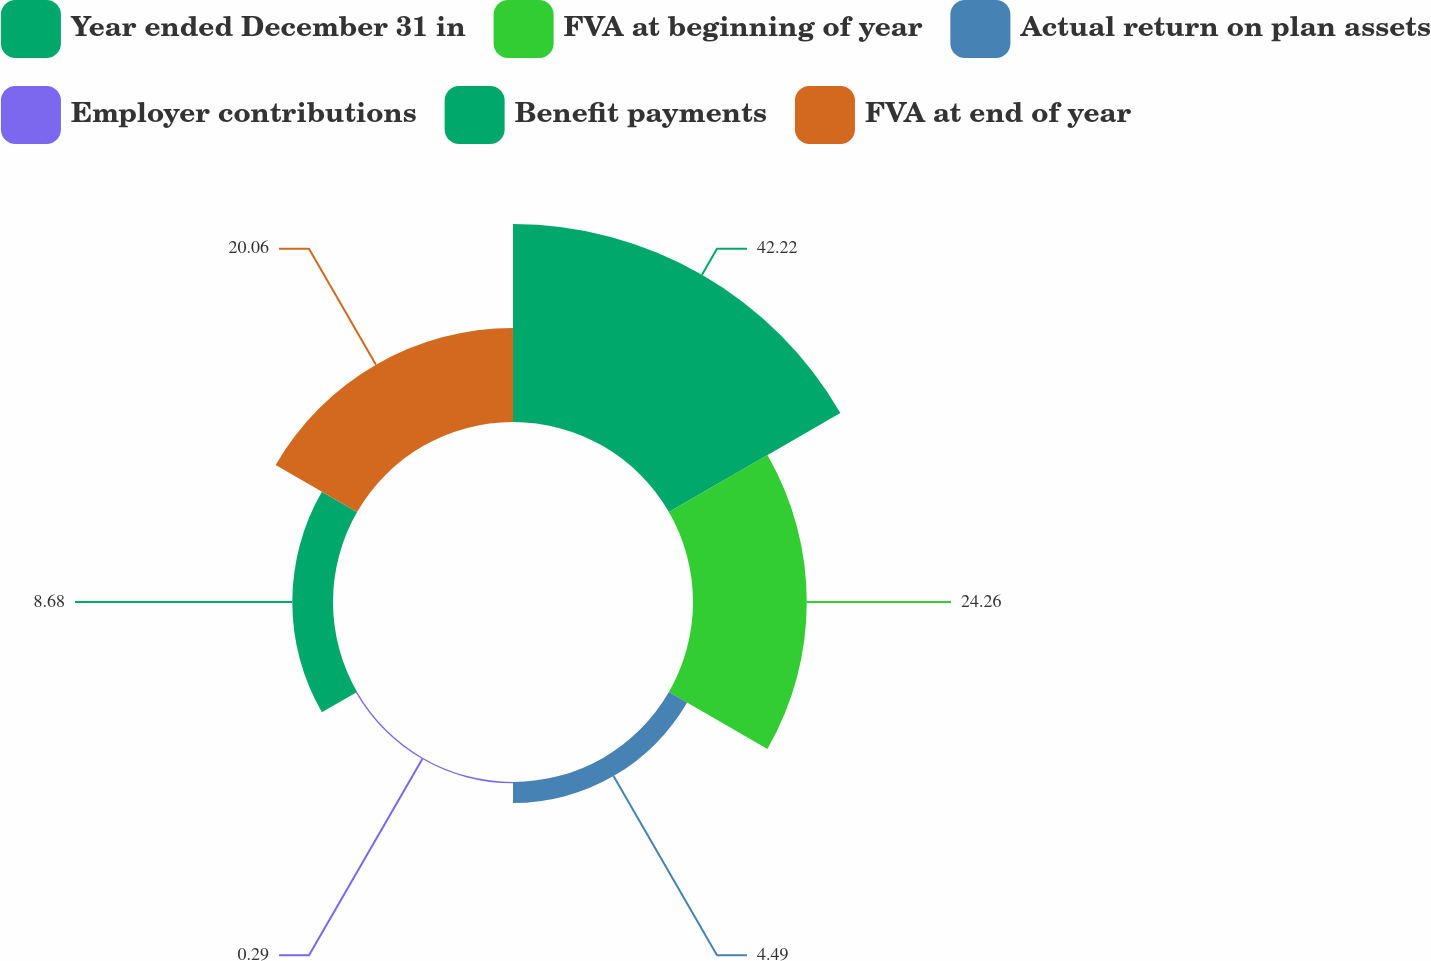Convert chart. <chart><loc_0><loc_0><loc_500><loc_500><pie_chart><fcel>Year ended December 31 in<fcel>FVA at beginning of year<fcel>Actual return on plan assets<fcel>Employer contributions<fcel>Benefit payments<fcel>FVA at end of year<nl><fcel>42.22%<fcel>24.26%<fcel>4.49%<fcel>0.29%<fcel>8.68%<fcel>20.06%<nl></chart> 